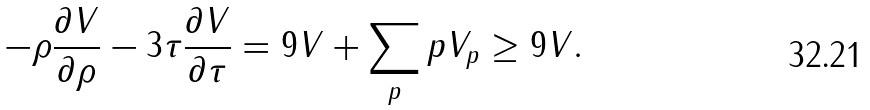Convert formula to latex. <formula><loc_0><loc_0><loc_500><loc_500>- \rho \frac { \partial V } { \partial \rho } - 3 \tau \frac { \partial V } { \partial \tau } = 9 V + \sum _ { p } p V _ { p } \geq 9 V .</formula> 